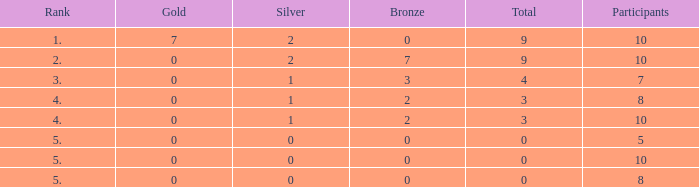What is listed as the highest Participants that also have a Rank of 5, and Silver that's smaller than 0? None. 